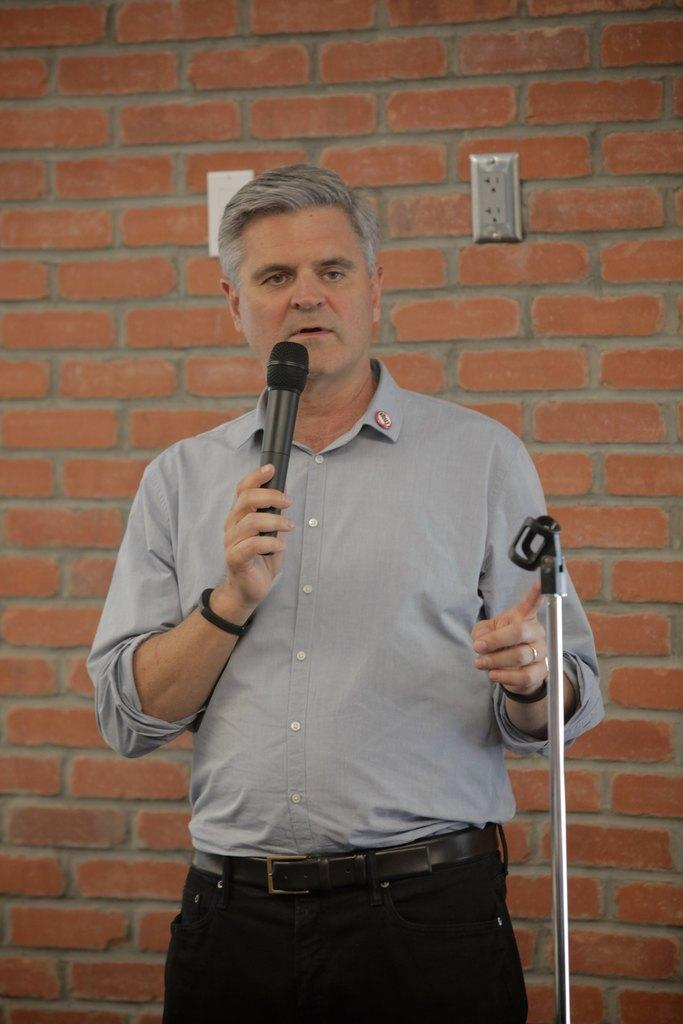Who or what is the main subject in the image? There is a person in the image. What is the person doing in the image? The person is standing in the image. What object is the person holding in their hands? The person is holding a microphone in their hands. What can be seen behind the person in the image? There is a wall in the background of the image. Where is the nest located in the image? There is no nest present in the image. What time of day is it in the image? The provided facts do not give any information about the time of day in the image. 